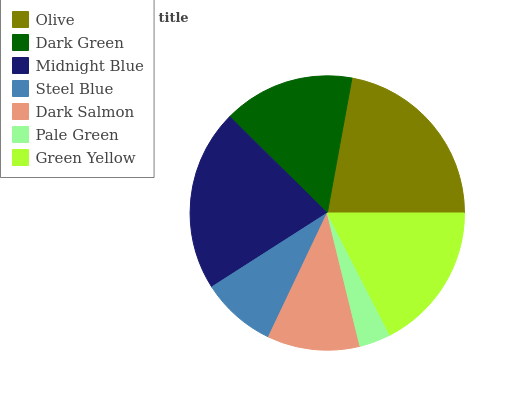Is Pale Green the minimum?
Answer yes or no. Yes. Is Olive the maximum?
Answer yes or no. Yes. Is Dark Green the minimum?
Answer yes or no. No. Is Dark Green the maximum?
Answer yes or no. No. Is Olive greater than Dark Green?
Answer yes or no. Yes. Is Dark Green less than Olive?
Answer yes or no. Yes. Is Dark Green greater than Olive?
Answer yes or no. No. Is Olive less than Dark Green?
Answer yes or no. No. Is Dark Green the high median?
Answer yes or no. Yes. Is Dark Green the low median?
Answer yes or no. Yes. Is Olive the high median?
Answer yes or no. No. Is Green Yellow the low median?
Answer yes or no. No. 